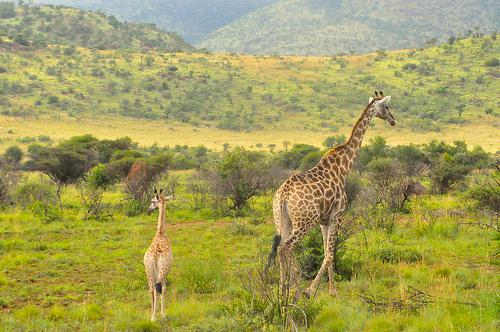Question: what is in the background?
Choices:
A. Mountains.
B. Ocean.
C. Hills.
D. Buildings.
Answer with the letter. Answer: C Question: what color are the giraffes?
Choices:
A. White.
B. Orange.
C. Black and white.
D. Brown and white.
Answer with the letter. Answer: D Question: what is the age relation of the giraffes?
Choices:
A. One is the mom.
B. One is younger.
C. One is the baby.
D. One is three years older.
Answer with the letter. Answer: B Question: where was this picture taken?
Choices:
A. Asia.
B. Africa.
C. Europe.
D. Australia.
Answer with the letter. Answer: B Question: how is the weather?
Choices:
A. Cloudy.
B. Rainy.
C. Snowy.
D. Sunny.
Answer with the letter. Answer: D 